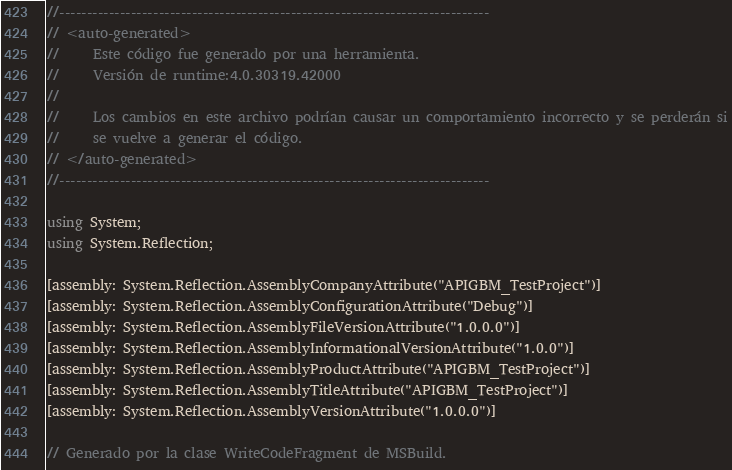Convert code to text. <code><loc_0><loc_0><loc_500><loc_500><_C#_>//------------------------------------------------------------------------------
// <auto-generated>
//     Este código fue generado por una herramienta.
//     Versión de runtime:4.0.30319.42000
//
//     Los cambios en este archivo podrían causar un comportamiento incorrecto y se perderán si
//     se vuelve a generar el código.
// </auto-generated>
//------------------------------------------------------------------------------

using System;
using System.Reflection;

[assembly: System.Reflection.AssemblyCompanyAttribute("APIGBM_TestProject")]
[assembly: System.Reflection.AssemblyConfigurationAttribute("Debug")]
[assembly: System.Reflection.AssemblyFileVersionAttribute("1.0.0.0")]
[assembly: System.Reflection.AssemblyInformationalVersionAttribute("1.0.0")]
[assembly: System.Reflection.AssemblyProductAttribute("APIGBM_TestProject")]
[assembly: System.Reflection.AssemblyTitleAttribute("APIGBM_TestProject")]
[assembly: System.Reflection.AssemblyVersionAttribute("1.0.0.0")]

// Generado por la clase WriteCodeFragment de MSBuild.

</code> 